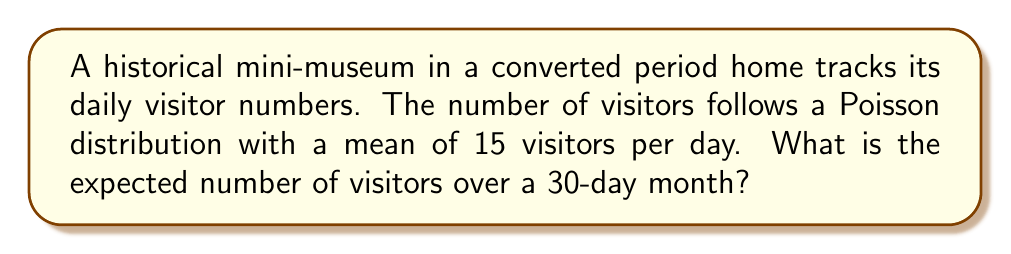Can you answer this question? Let's approach this step-by-step:

1) The Poisson distribution is used to model the number of events occurring in a fixed interval of time or space, given a known average rate.

2) In this case, we have:
   - Average number of visitors per day: $\lambda = 15$
   - Number of days: $n = 30$

3) For a Poisson distribution, the expected value (mean) for a single day is equal to $\lambda$:

   $E(X) = \lambda = 15$

4) We want to find the expected number of visitors over 30 days. Since the number of visitors each day is independent, we can use the linearity of expectation:

   $E(X_1 + X_2 + ... + X_{30}) = E(X_1) + E(X_2) + ... + E(X_{30})$

5) As each day has the same expected value, this simplifies to:

   $E(\text{total visitors}) = 30 \times E(X) = 30 \times 15 = 450$

Therefore, the expected number of visitors over a 30-day month is 450.
Answer: 450 visitors 